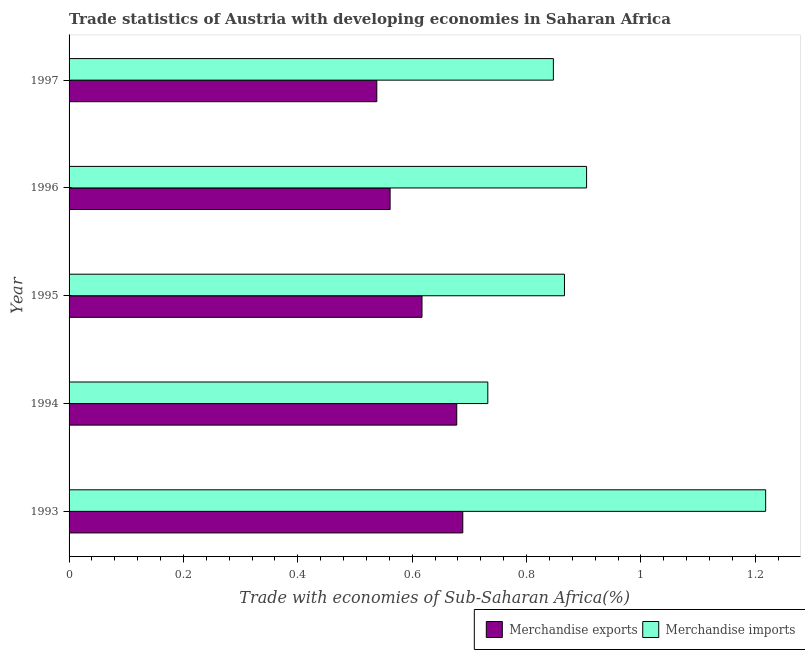Are the number of bars per tick equal to the number of legend labels?
Provide a succinct answer. Yes. How many bars are there on the 4th tick from the top?
Your answer should be very brief. 2. What is the merchandise imports in 1995?
Make the answer very short. 0.87. Across all years, what is the maximum merchandise exports?
Offer a very short reply. 0.69. Across all years, what is the minimum merchandise imports?
Ensure brevity in your answer.  0.73. In which year was the merchandise exports maximum?
Make the answer very short. 1993. What is the total merchandise imports in the graph?
Your response must be concise. 4.57. What is the difference between the merchandise imports in 1993 and that in 1997?
Offer a very short reply. 0.37. What is the difference between the merchandise exports in 1995 and the merchandise imports in 1997?
Give a very brief answer. -0.23. What is the average merchandise exports per year?
Make the answer very short. 0.62. In the year 1995, what is the difference between the merchandise exports and merchandise imports?
Your answer should be compact. -0.25. What is the ratio of the merchandise exports in 1994 to that in 1996?
Ensure brevity in your answer.  1.21. Is the difference between the merchandise imports in 1995 and 1996 greater than the difference between the merchandise exports in 1995 and 1996?
Provide a succinct answer. No. What is the difference between the highest and the second highest merchandise exports?
Your answer should be compact. 0.01. Is the sum of the merchandise exports in 1994 and 1995 greater than the maximum merchandise imports across all years?
Keep it short and to the point. Yes. What does the 2nd bar from the top in 1995 represents?
Your answer should be compact. Merchandise exports. How many years are there in the graph?
Keep it short and to the point. 5. Does the graph contain any zero values?
Provide a short and direct response. No. How are the legend labels stacked?
Your answer should be very brief. Horizontal. What is the title of the graph?
Your response must be concise. Trade statistics of Austria with developing economies in Saharan Africa. Does "Crop" appear as one of the legend labels in the graph?
Ensure brevity in your answer.  No. What is the label or title of the X-axis?
Your answer should be very brief. Trade with economies of Sub-Saharan Africa(%). What is the label or title of the Y-axis?
Your answer should be very brief. Year. What is the Trade with economies of Sub-Saharan Africa(%) of Merchandise exports in 1993?
Your response must be concise. 0.69. What is the Trade with economies of Sub-Saharan Africa(%) in Merchandise imports in 1993?
Your response must be concise. 1.22. What is the Trade with economies of Sub-Saharan Africa(%) of Merchandise exports in 1994?
Offer a very short reply. 0.68. What is the Trade with economies of Sub-Saharan Africa(%) in Merchandise imports in 1994?
Your answer should be compact. 0.73. What is the Trade with economies of Sub-Saharan Africa(%) of Merchandise exports in 1995?
Give a very brief answer. 0.62. What is the Trade with economies of Sub-Saharan Africa(%) of Merchandise imports in 1995?
Keep it short and to the point. 0.87. What is the Trade with economies of Sub-Saharan Africa(%) in Merchandise exports in 1996?
Your answer should be compact. 0.56. What is the Trade with economies of Sub-Saharan Africa(%) in Merchandise imports in 1996?
Your response must be concise. 0.91. What is the Trade with economies of Sub-Saharan Africa(%) of Merchandise exports in 1997?
Your answer should be compact. 0.54. What is the Trade with economies of Sub-Saharan Africa(%) of Merchandise imports in 1997?
Give a very brief answer. 0.85. Across all years, what is the maximum Trade with economies of Sub-Saharan Africa(%) of Merchandise exports?
Keep it short and to the point. 0.69. Across all years, what is the maximum Trade with economies of Sub-Saharan Africa(%) of Merchandise imports?
Ensure brevity in your answer.  1.22. Across all years, what is the minimum Trade with economies of Sub-Saharan Africa(%) in Merchandise exports?
Offer a terse response. 0.54. Across all years, what is the minimum Trade with economies of Sub-Saharan Africa(%) in Merchandise imports?
Keep it short and to the point. 0.73. What is the total Trade with economies of Sub-Saharan Africa(%) in Merchandise exports in the graph?
Offer a very short reply. 3.08. What is the total Trade with economies of Sub-Saharan Africa(%) of Merchandise imports in the graph?
Provide a short and direct response. 4.57. What is the difference between the Trade with economies of Sub-Saharan Africa(%) of Merchandise exports in 1993 and that in 1994?
Your response must be concise. 0.01. What is the difference between the Trade with economies of Sub-Saharan Africa(%) in Merchandise imports in 1993 and that in 1994?
Make the answer very short. 0.49. What is the difference between the Trade with economies of Sub-Saharan Africa(%) of Merchandise exports in 1993 and that in 1995?
Offer a terse response. 0.07. What is the difference between the Trade with economies of Sub-Saharan Africa(%) in Merchandise imports in 1993 and that in 1995?
Your response must be concise. 0.35. What is the difference between the Trade with economies of Sub-Saharan Africa(%) of Merchandise exports in 1993 and that in 1996?
Provide a succinct answer. 0.13. What is the difference between the Trade with economies of Sub-Saharan Africa(%) in Merchandise imports in 1993 and that in 1996?
Keep it short and to the point. 0.31. What is the difference between the Trade with economies of Sub-Saharan Africa(%) of Merchandise exports in 1993 and that in 1997?
Make the answer very short. 0.15. What is the difference between the Trade with economies of Sub-Saharan Africa(%) in Merchandise imports in 1993 and that in 1997?
Your answer should be compact. 0.37. What is the difference between the Trade with economies of Sub-Saharan Africa(%) of Merchandise exports in 1994 and that in 1995?
Give a very brief answer. 0.06. What is the difference between the Trade with economies of Sub-Saharan Africa(%) in Merchandise imports in 1994 and that in 1995?
Ensure brevity in your answer.  -0.13. What is the difference between the Trade with economies of Sub-Saharan Africa(%) in Merchandise exports in 1994 and that in 1996?
Provide a succinct answer. 0.12. What is the difference between the Trade with economies of Sub-Saharan Africa(%) in Merchandise imports in 1994 and that in 1996?
Keep it short and to the point. -0.17. What is the difference between the Trade with economies of Sub-Saharan Africa(%) in Merchandise exports in 1994 and that in 1997?
Offer a very short reply. 0.14. What is the difference between the Trade with economies of Sub-Saharan Africa(%) in Merchandise imports in 1994 and that in 1997?
Your answer should be compact. -0.11. What is the difference between the Trade with economies of Sub-Saharan Africa(%) in Merchandise exports in 1995 and that in 1996?
Your answer should be very brief. 0.06. What is the difference between the Trade with economies of Sub-Saharan Africa(%) of Merchandise imports in 1995 and that in 1996?
Provide a succinct answer. -0.04. What is the difference between the Trade with economies of Sub-Saharan Africa(%) of Merchandise exports in 1995 and that in 1997?
Provide a succinct answer. 0.08. What is the difference between the Trade with economies of Sub-Saharan Africa(%) in Merchandise imports in 1995 and that in 1997?
Give a very brief answer. 0.02. What is the difference between the Trade with economies of Sub-Saharan Africa(%) in Merchandise exports in 1996 and that in 1997?
Offer a terse response. 0.02. What is the difference between the Trade with economies of Sub-Saharan Africa(%) in Merchandise imports in 1996 and that in 1997?
Your answer should be very brief. 0.06. What is the difference between the Trade with economies of Sub-Saharan Africa(%) in Merchandise exports in 1993 and the Trade with economies of Sub-Saharan Africa(%) in Merchandise imports in 1994?
Your answer should be very brief. -0.04. What is the difference between the Trade with economies of Sub-Saharan Africa(%) of Merchandise exports in 1993 and the Trade with economies of Sub-Saharan Africa(%) of Merchandise imports in 1995?
Give a very brief answer. -0.18. What is the difference between the Trade with economies of Sub-Saharan Africa(%) in Merchandise exports in 1993 and the Trade with economies of Sub-Saharan Africa(%) in Merchandise imports in 1996?
Offer a very short reply. -0.22. What is the difference between the Trade with economies of Sub-Saharan Africa(%) in Merchandise exports in 1993 and the Trade with economies of Sub-Saharan Africa(%) in Merchandise imports in 1997?
Provide a succinct answer. -0.16. What is the difference between the Trade with economies of Sub-Saharan Africa(%) in Merchandise exports in 1994 and the Trade with economies of Sub-Saharan Africa(%) in Merchandise imports in 1995?
Your answer should be very brief. -0.19. What is the difference between the Trade with economies of Sub-Saharan Africa(%) of Merchandise exports in 1994 and the Trade with economies of Sub-Saharan Africa(%) of Merchandise imports in 1996?
Make the answer very short. -0.23. What is the difference between the Trade with economies of Sub-Saharan Africa(%) of Merchandise exports in 1994 and the Trade with economies of Sub-Saharan Africa(%) of Merchandise imports in 1997?
Ensure brevity in your answer.  -0.17. What is the difference between the Trade with economies of Sub-Saharan Africa(%) in Merchandise exports in 1995 and the Trade with economies of Sub-Saharan Africa(%) in Merchandise imports in 1996?
Provide a short and direct response. -0.29. What is the difference between the Trade with economies of Sub-Saharan Africa(%) of Merchandise exports in 1995 and the Trade with economies of Sub-Saharan Africa(%) of Merchandise imports in 1997?
Provide a short and direct response. -0.23. What is the difference between the Trade with economies of Sub-Saharan Africa(%) of Merchandise exports in 1996 and the Trade with economies of Sub-Saharan Africa(%) of Merchandise imports in 1997?
Offer a terse response. -0.29. What is the average Trade with economies of Sub-Saharan Africa(%) in Merchandise exports per year?
Offer a very short reply. 0.62. What is the average Trade with economies of Sub-Saharan Africa(%) of Merchandise imports per year?
Your response must be concise. 0.91. In the year 1993, what is the difference between the Trade with economies of Sub-Saharan Africa(%) of Merchandise exports and Trade with economies of Sub-Saharan Africa(%) of Merchandise imports?
Offer a terse response. -0.53. In the year 1994, what is the difference between the Trade with economies of Sub-Saharan Africa(%) in Merchandise exports and Trade with economies of Sub-Saharan Africa(%) in Merchandise imports?
Give a very brief answer. -0.05. In the year 1995, what is the difference between the Trade with economies of Sub-Saharan Africa(%) of Merchandise exports and Trade with economies of Sub-Saharan Africa(%) of Merchandise imports?
Offer a very short reply. -0.25. In the year 1996, what is the difference between the Trade with economies of Sub-Saharan Africa(%) in Merchandise exports and Trade with economies of Sub-Saharan Africa(%) in Merchandise imports?
Provide a succinct answer. -0.34. In the year 1997, what is the difference between the Trade with economies of Sub-Saharan Africa(%) in Merchandise exports and Trade with economies of Sub-Saharan Africa(%) in Merchandise imports?
Make the answer very short. -0.31. What is the ratio of the Trade with economies of Sub-Saharan Africa(%) in Merchandise exports in 1993 to that in 1994?
Provide a short and direct response. 1.02. What is the ratio of the Trade with economies of Sub-Saharan Africa(%) of Merchandise imports in 1993 to that in 1994?
Keep it short and to the point. 1.66. What is the ratio of the Trade with economies of Sub-Saharan Africa(%) in Merchandise exports in 1993 to that in 1995?
Your answer should be very brief. 1.12. What is the ratio of the Trade with economies of Sub-Saharan Africa(%) of Merchandise imports in 1993 to that in 1995?
Provide a short and direct response. 1.41. What is the ratio of the Trade with economies of Sub-Saharan Africa(%) of Merchandise exports in 1993 to that in 1996?
Offer a very short reply. 1.23. What is the ratio of the Trade with economies of Sub-Saharan Africa(%) of Merchandise imports in 1993 to that in 1996?
Ensure brevity in your answer.  1.35. What is the ratio of the Trade with economies of Sub-Saharan Africa(%) in Merchandise exports in 1993 to that in 1997?
Make the answer very short. 1.28. What is the ratio of the Trade with economies of Sub-Saharan Africa(%) of Merchandise imports in 1993 to that in 1997?
Provide a succinct answer. 1.44. What is the ratio of the Trade with economies of Sub-Saharan Africa(%) of Merchandise exports in 1994 to that in 1995?
Your response must be concise. 1.1. What is the ratio of the Trade with economies of Sub-Saharan Africa(%) in Merchandise imports in 1994 to that in 1995?
Offer a terse response. 0.85. What is the ratio of the Trade with economies of Sub-Saharan Africa(%) in Merchandise exports in 1994 to that in 1996?
Offer a very short reply. 1.21. What is the ratio of the Trade with economies of Sub-Saharan Africa(%) of Merchandise imports in 1994 to that in 1996?
Ensure brevity in your answer.  0.81. What is the ratio of the Trade with economies of Sub-Saharan Africa(%) in Merchandise exports in 1994 to that in 1997?
Your answer should be compact. 1.26. What is the ratio of the Trade with economies of Sub-Saharan Africa(%) of Merchandise imports in 1994 to that in 1997?
Your answer should be very brief. 0.86. What is the ratio of the Trade with economies of Sub-Saharan Africa(%) of Merchandise exports in 1995 to that in 1996?
Provide a short and direct response. 1.1. What is the ratio of the Trade with economies of Sub-Saharan Africa(%) in Merchandise imports in 1995 to that in 1996?
Keep it short and to the point. 0.96. What is the ratio of the Trade with economies of Sub-Saharan Africa(%) of Merchandise exports in 1995 to that in 1997?
Keep it short and to the point. 1.15. What is the ratio of the Trade with economies of Sub-Saharan Africa(%) in Merchandise imports in 1995 to that in 1997?
Your response must be concise. 1.02. What is the ratio of the Trade with economies of Sub-Saharan Africa(%) of Merchandise exports in 1996 to that in 1997?
Offer a terse response. 1.04. What is the ratio of the Trade with economies of Sub-Saharan Africa(%) in Merchandise imports in 1996 to that in 1997?
Keep it short and to the point. 1.07. What is the difference between the highest and the second highest Trade with economies of Sub-Saharan Africa(%) of Merchandise exports?
Offer a terse response. 0.01. What is the difference between the highest and the second highest Trade with economies of Sub-Saharan Africa(%) of Merchandise imports?
Your answer should be very brief. 0.31. What is the difference between the highest and the lowest Trade with economies of Sub-Saharan Africa(%) of Merchandise exports?
Offer a very short reply. 0.15. What is the difference between the highest and the lowest Trade with economies of Sub-Saharan Africa(%) in Merchandise imports?
Provide a short and direct response. 0.49. 